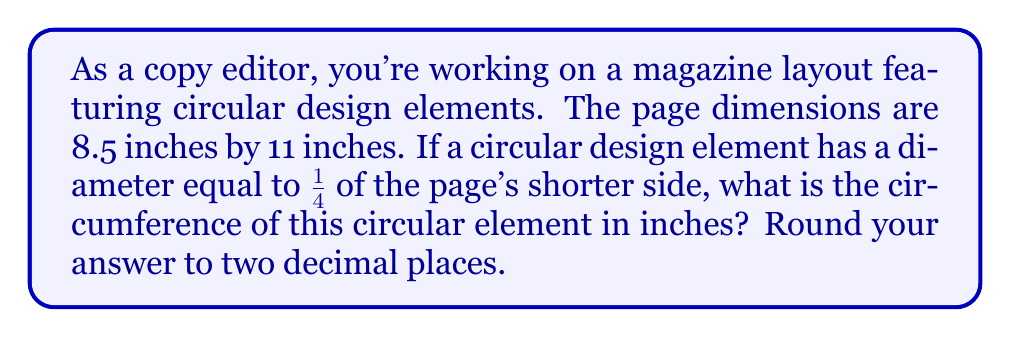Help me with this question. To solve this problem, let's break it down into steps:

1. Identify the shorter side of the page:
   The shorter side is 8.5 inches.

2. Calculate the diameter of the circular design element:
   $$\text{Diameter} = \frac{1}{4} \times 8.5\text{ inches} = 2.125\text{ inches}$$

3. Find the radius of the circular design element:
   $$\text{Radius} = \frac{\text{Diameter}}{2} = \frac{2.125}{2} = 1.0625\text{ inches}$$

4. Use the formula for circumference of a circle:
   $$C = 2\pi r$$
   Where $C$ is the circumference and $r$ is the radius.

5. Calculate the circumference:
   $$C = 2\pi(1.0625) \approx 6.6759\text{ inches}$$

6. Round the result to two decimal places:
   $$C \approx 6.68\text{ inches}$$

[asy]
unitsize(1cm);
draw((0,0)--(8.5,0)--(8.5,11)--(0,11)--cycle);
draw(circle((4.25,5.5),1.0625));
label("8.5\"", (4.25,-0.5));
label("11\"", (9,5.5));
label("2.125\"", (4.25,4));
[/asy]
Answer: The circumference of the circular design element is approximately 6.68 inches. 